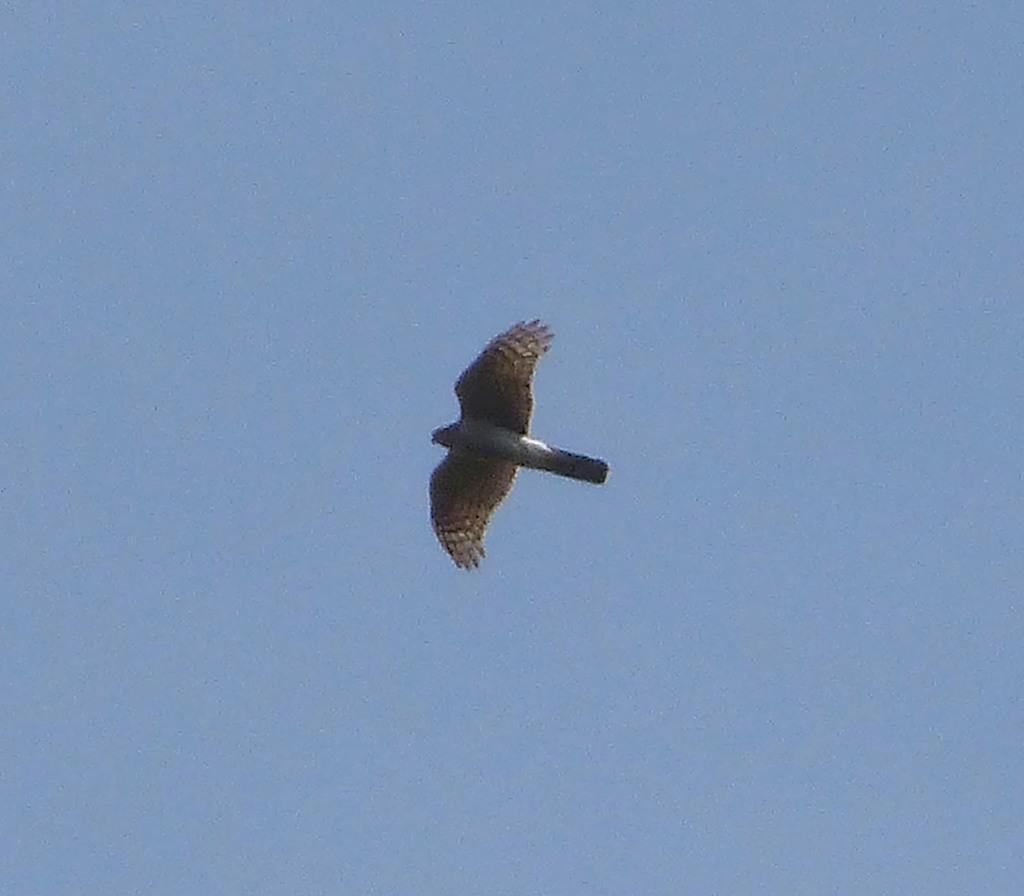In one or two sentences, can you explain what this image depicts? In the given image i can see a bird and sky. 